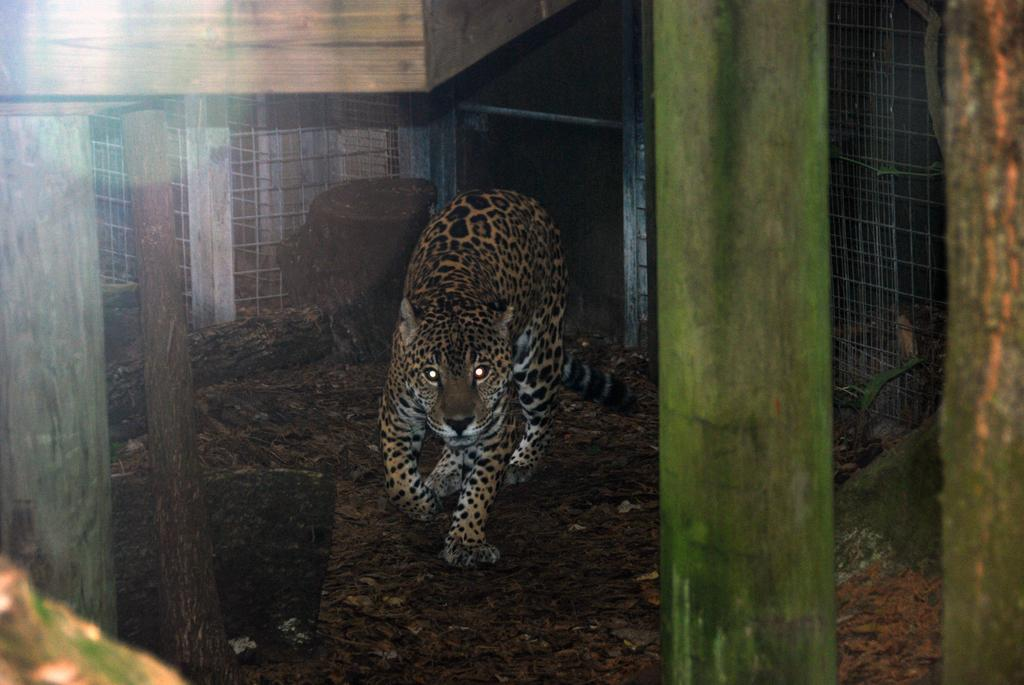What type of animal is in the image? The type of animal cannot be determined from the provided facts. What material are the logs in the image made of? The logs in the image are made of wood. What type of barrier is in the image? There is a metal fence in the image. What religious symbol can be seen in the image? There is no religious symbol present in the image. Can you describe the harbor in the image? There is no harbor present in the image. 